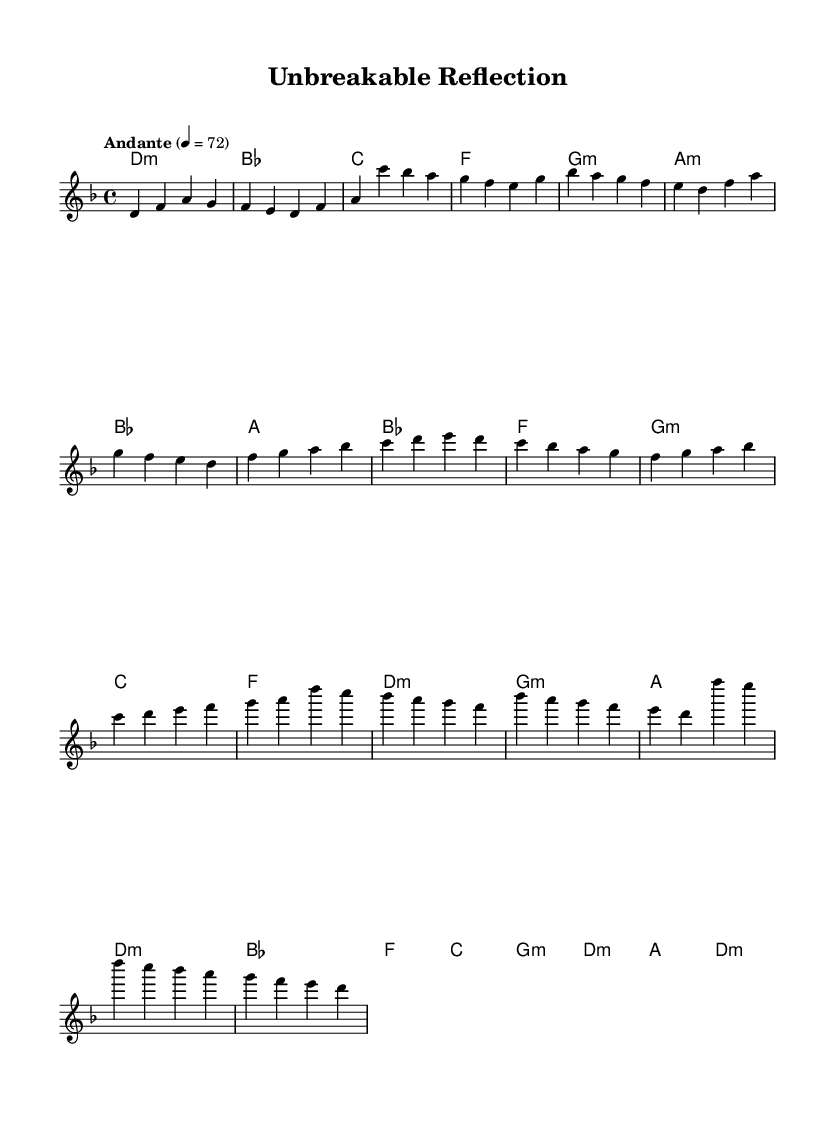What is the key signature of this music? The key signature is determined by the starting note of the melody and the presence of sharps or flats. In this case, it is written in D minor, which has one flat (B flat).
Answer: D minor What is the time signature of the piece? The time signature is indicated at the beginning of the sheet music, where it shows how many beats are in each measure. Here, it shows 4/4, meaning there are four beats per measure.
Answer: 4/4 What is the tempo marking for this piece? The tempo is specified in the sheet music by the term "Andante," which indicates a moderate pace, often interpreted as moving at a speed of about 76 to 108 beats per minute. The specific marking here shows the metronome marking as 72 beats per minute.
Answer: Andante How many sections are in this piece? The music is organized into several distinct parts, including a Verse, Pre-chorus, and Chorus, which reflects a common structure in K-Pop ballads. Based on the sections indicated, there are three main sections noted in the music.
Answer: Three Identify the harmonic progression in the chorus. The harmonic progression can be determined by looking at the chord changes under the melody in the chorus section. The chords listed for the chorus are D minor, B flat, F, C, G minor, D minor, A, and D minor, representing common harmonic motion in K-Pop ballads.
Answer: D minor, B flat, F, C, G minor, D minor, A, D minor What thematic element does this K-Pop ballad represent? The thematic element is inferred from the title "Unbreakable Reflection" and the context of K-Pop ballads that often explore themes of high expectations and perfectionism. Thus, this piece reflects emotional pressure and striving for excellence.
Answer: Emotional pressure 